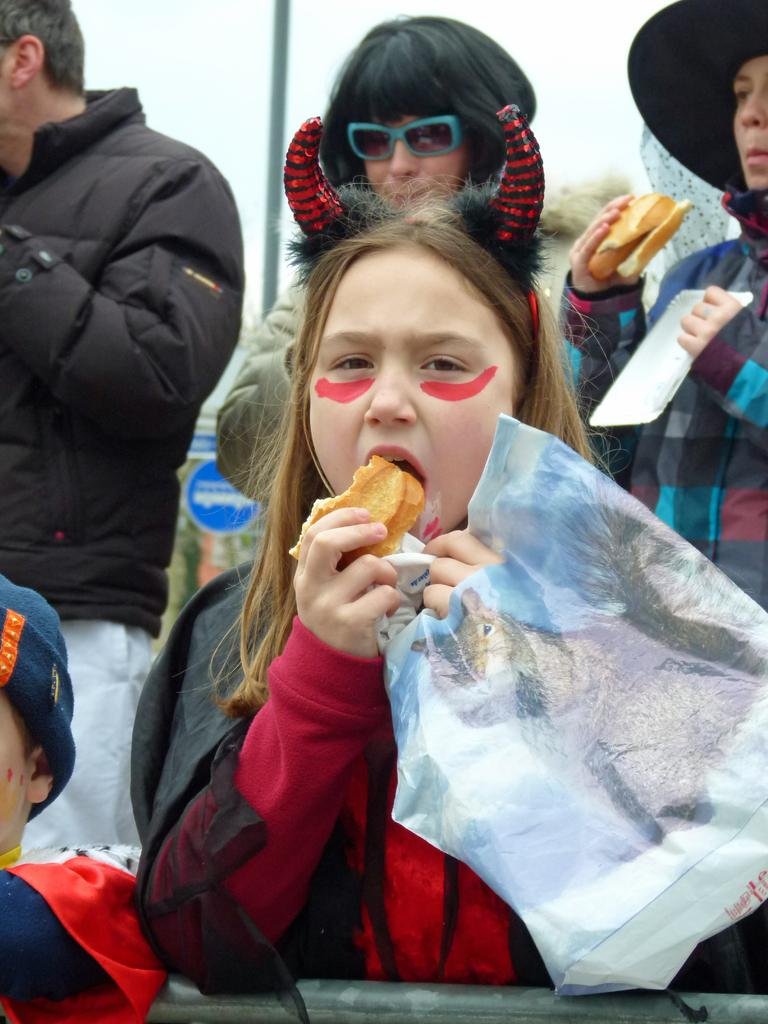What is the girl in the image holding? The girl is holding a bag and a food item. What is on the girl's head? The girl has horns on her head. What can be seen in the background of the image? There are persons, a pole, boards, and the sky visible in the background of the image. What type of ice can be seen in the image? There is no ice present in the image. What country is the girl from in the image? The image does not provide information about the girl's country of origin. 